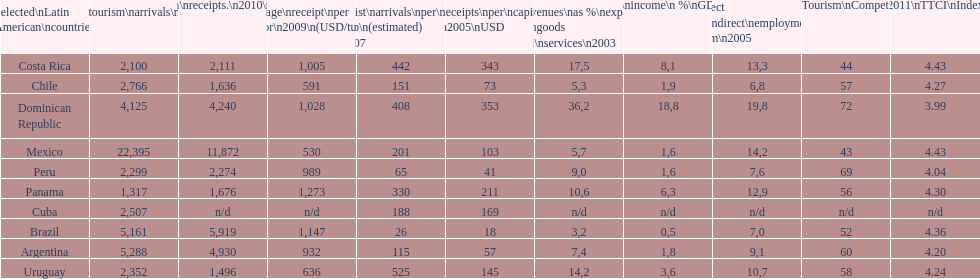What country had the least arrivals per 1000 inhabitants in 2007(estimated)? Brazil. 